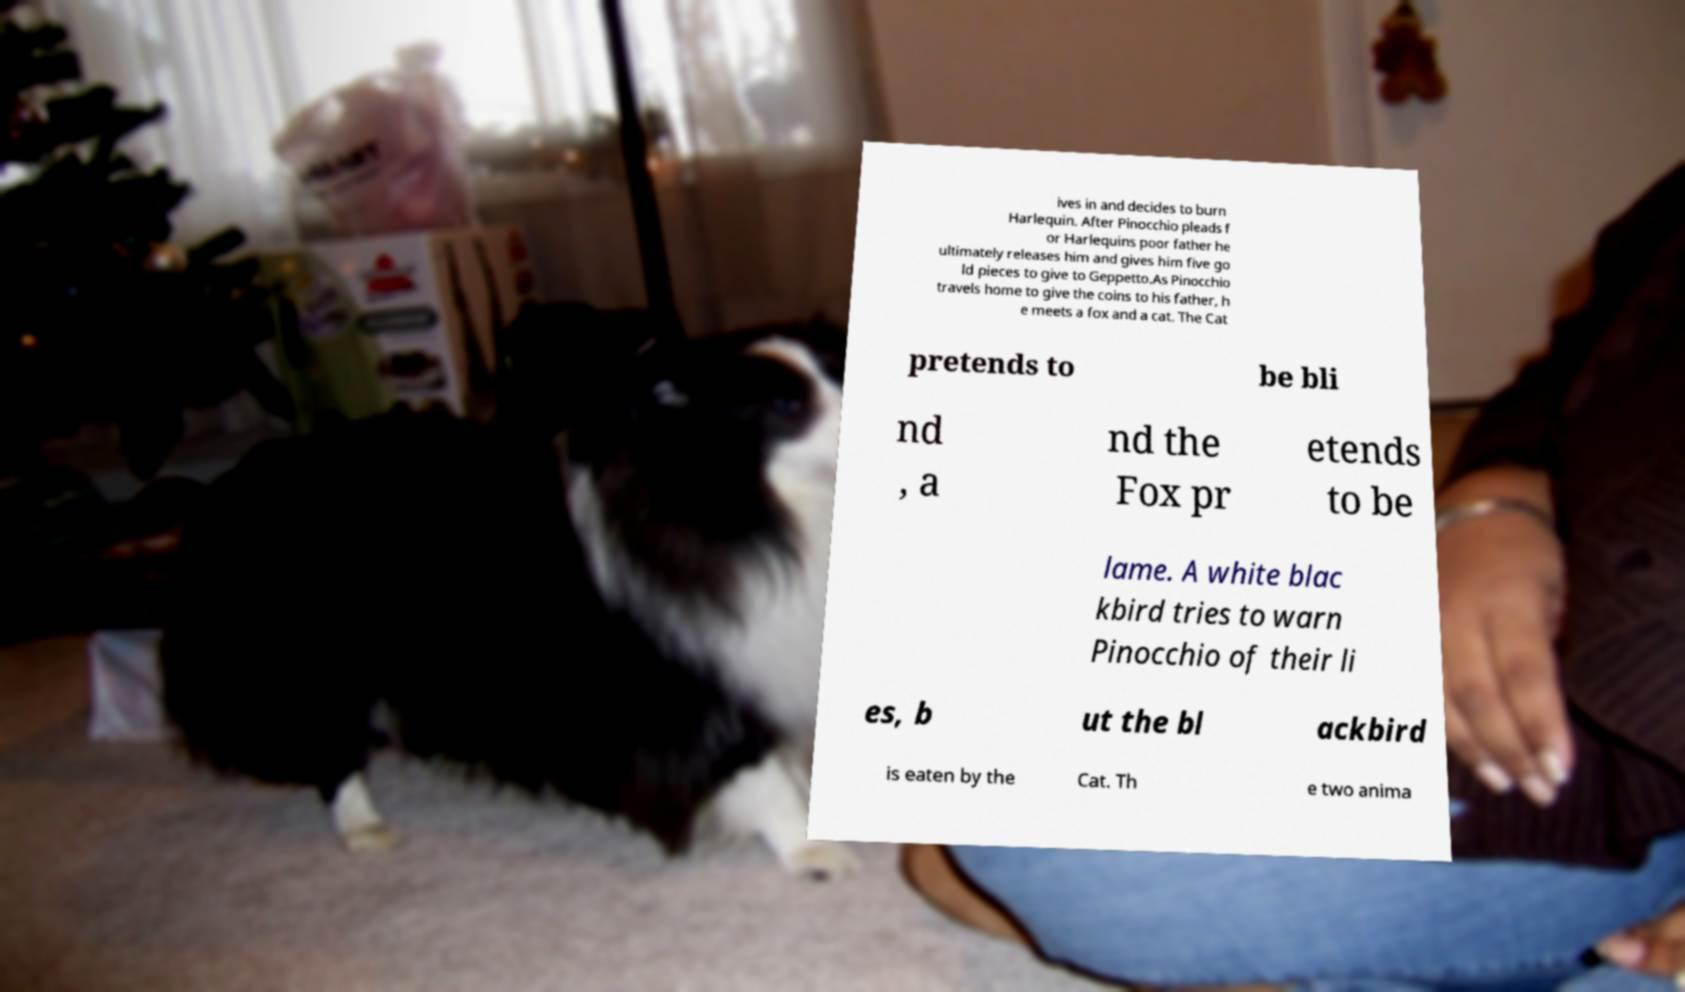Please identify and transcribe the text found in this image. ives in and decides to burn Harlequin. After Pinocchio pleads f or Harlequins poor father he ultimately releases him and gives him five go ld pieces to give to Geppetto.As Pinocchio travels home to give the coins to his father, h e meets a fox and a cat. The Cat pretends to be bli nd , a nd the Fox pr etends to be lame. A white blac kbird tries to warn Pinocchio of their li es, b ut the bl ackbird is eaten by the Cat. Th e two anima 